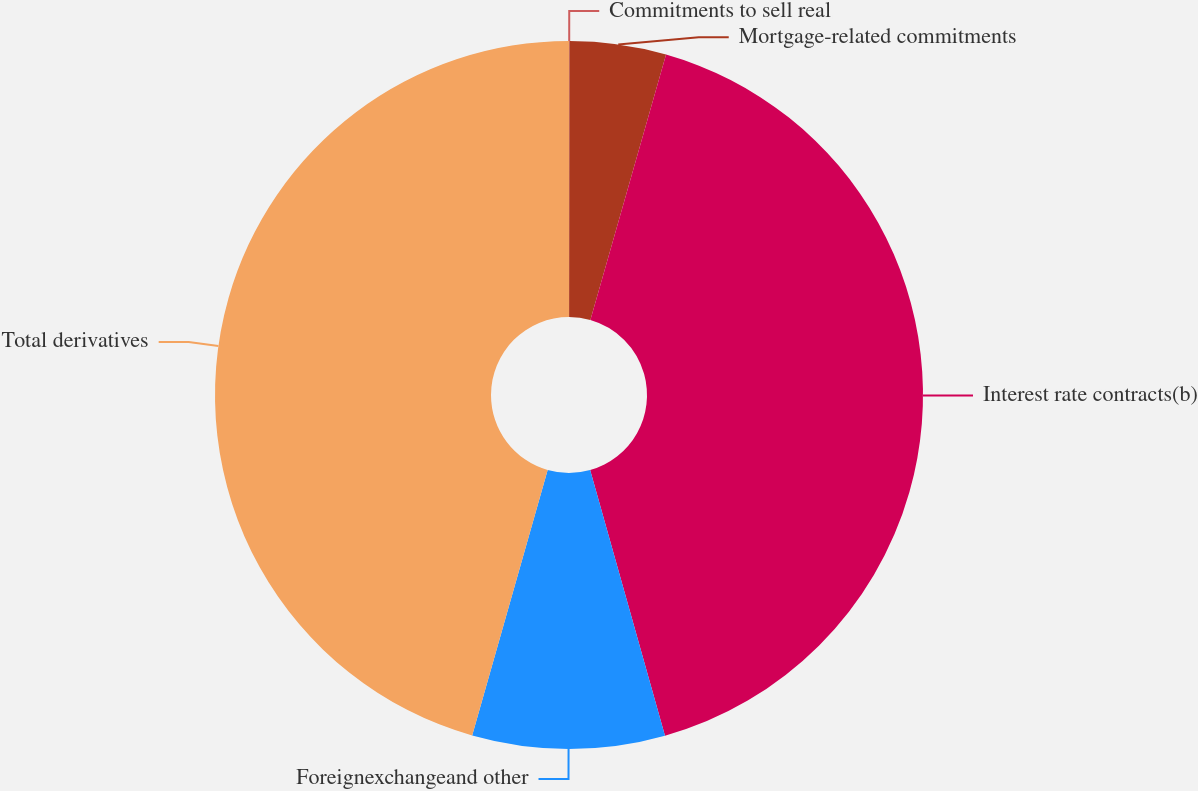Convert chart. <chart><loc_0><loc_0><loc_500><loc_500><pie_chart><fcel>Commitments to sell real<fcel>Mortgage-related commitments<fcel>Interest rate contracts(b)<fcel>Foreignexchangeand other<fcel>Total derivatives<nl><fcel>0.02%<fcel>4.4%<fcel>41.21%<fcel>8.78%<fcel>45.59%<nl></chart> 